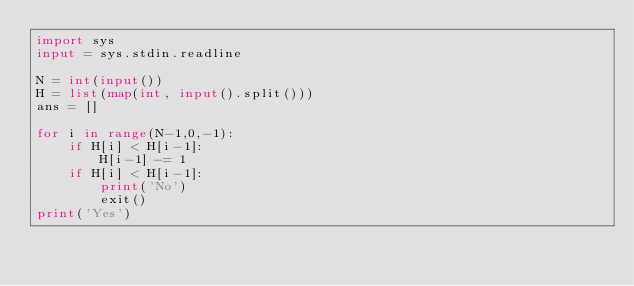Convert code to text. <code><loc_0><loc_0><loc_500><loc_500><_Python_>import sys
input = sys.stdin.readline

N = int(input())
H = list(map(int, input().split()))
ans = []

for i in range(N-1,0,-1):
    if H[i] < H[i-1]:
        H[i-1] -= 1
    if H[i] < H[i-1]:
        print('No')
        exit()
print('Yes')</code> 